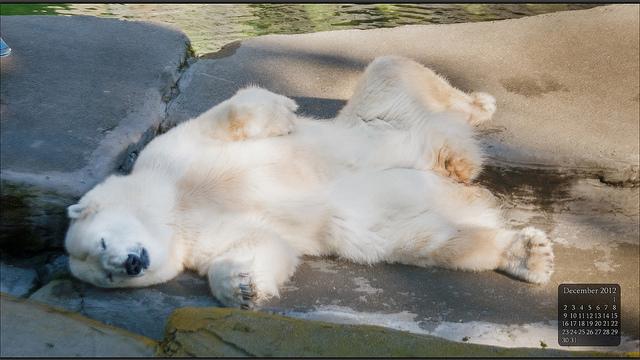Which way is the bear facing?
Keep it brief. Forward. Is the bear sleeping?
Write a very short answer. Yes. Is the polar bear's mouth closed?
Keep it brief. Yes. What month is shown on the calendar?
Concise answer only. December. Is this a natural habitat?
Concise answer only. No. Is the bears eyes open?
Quick response, please. No. How old does the bear look?
Answer briefly. 10. 